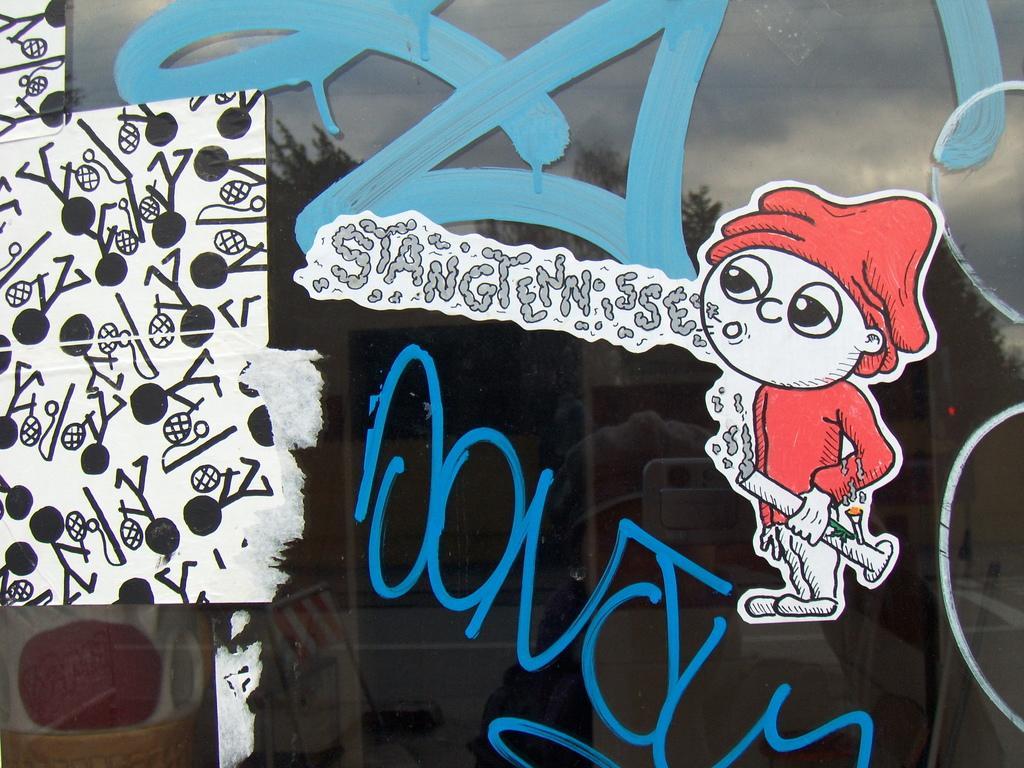Describe this image in one or two sentences. In this picture we can see an art on the glass. 